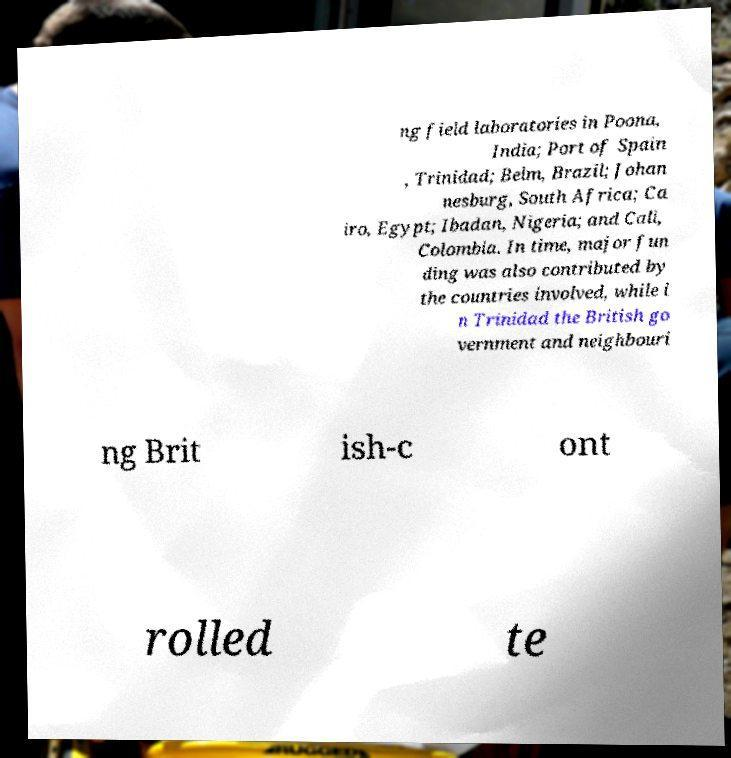Please identify and transcribe the text found in this image. ng field laboratories in Poona, India; Port of Spain , Trinidad; Belm, Brazil; Johan nesburg, South Africa; Ca iro, Egypt; Ibadan, Nigeria; and Cali, Colombia. In time, major fun ding was also contributed by the countries involved, while i n Trinidad the British go vernment and neighbouri ng Brit ish-c ont rolled te 